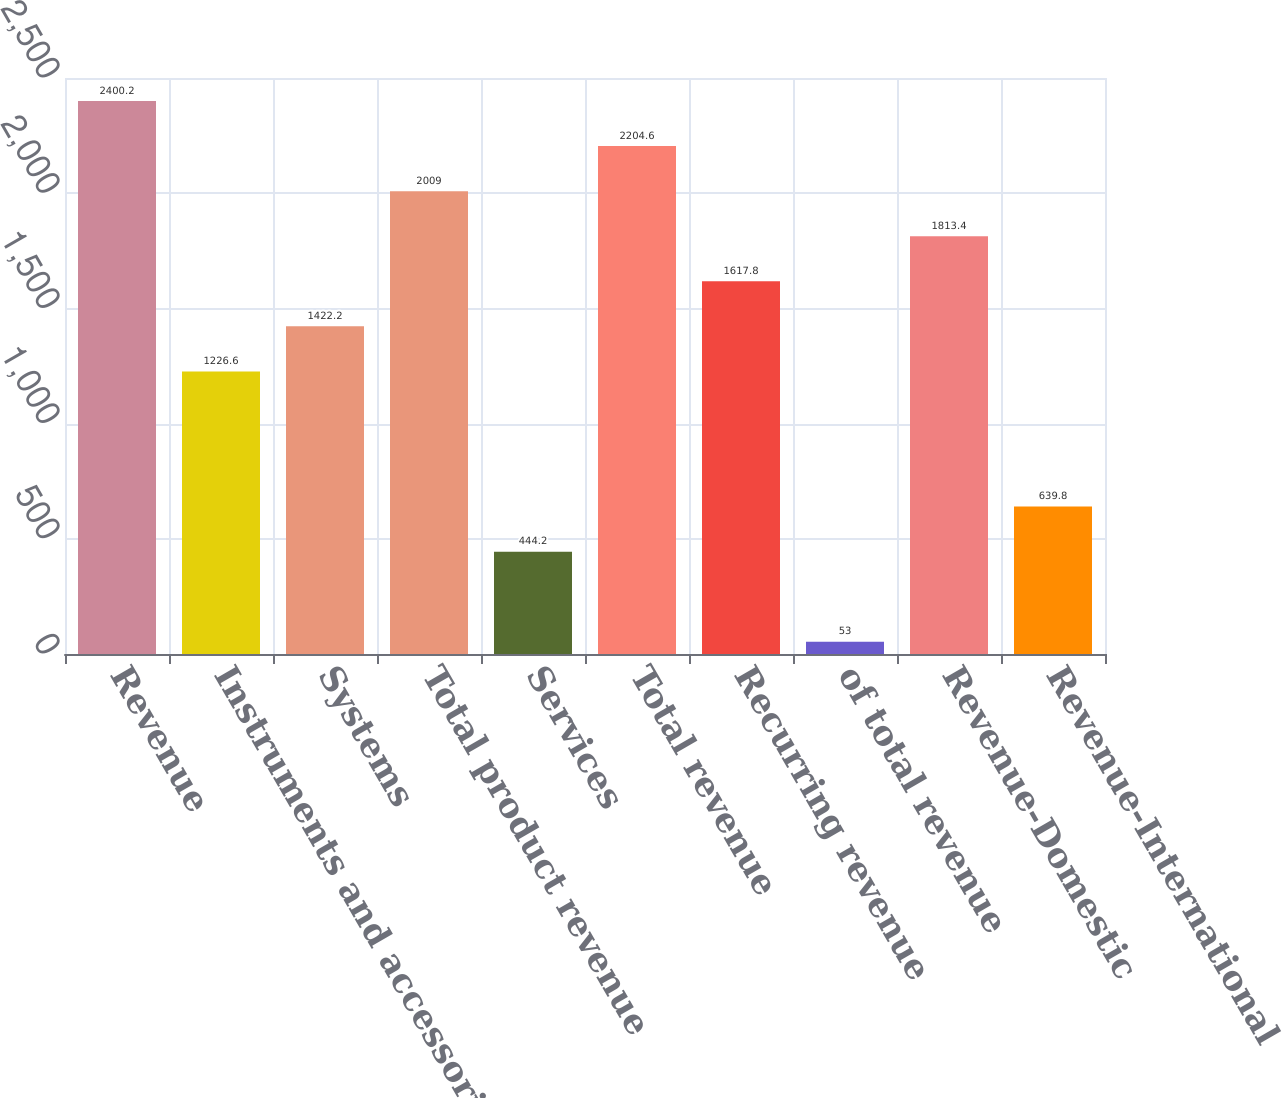<chart> <loc_0><loc_0><loc_500><loc_500><bar_chart><fcel>Revenue<fcel>Instruments and accessories<fcel>Systems<fcel>Total product revenue<fcel>Services<fcel>Total revenue<fcel>Recurring revenue<fcel>of total revenue<fcel>Revenue-Domestic<fcel>Revenue-International<nl><fcel>2400.2<fcel>1226.6<fcel>1422.2<fcel>2009<fcel>444.2<fcel>2204.6<fcel>1617.8<fcel>53<fcel>1813.4<fcel>639.8<nl></chart> 